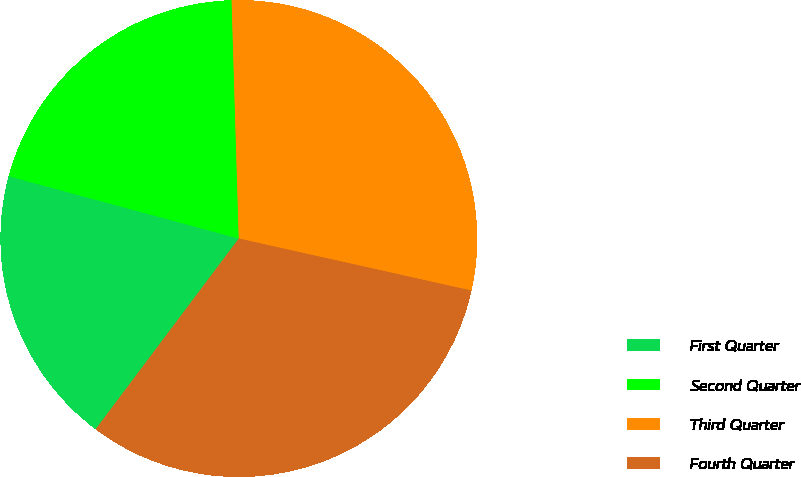Convert chart. <chart><loc_0><loc_0><loc_500><loc_500><pie_chart><fcel>First Quarter<fcel>Second Quarter<fcel>Third Quarter<fcel>Fourth Quarter<nl><fcel>18.96%<fcel>20.31%<fcel>28.98%<fcel>31.74%<nl></chart> 